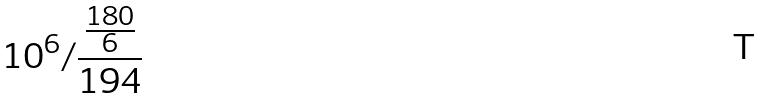Convert formula to latex. <formula><loc_0><loc_0><loc_500><loc_500>1 0 ^ { 6 } / \frac { \frac { 1 8 0 } { 6 } } { 1 9 4 }</formula> 